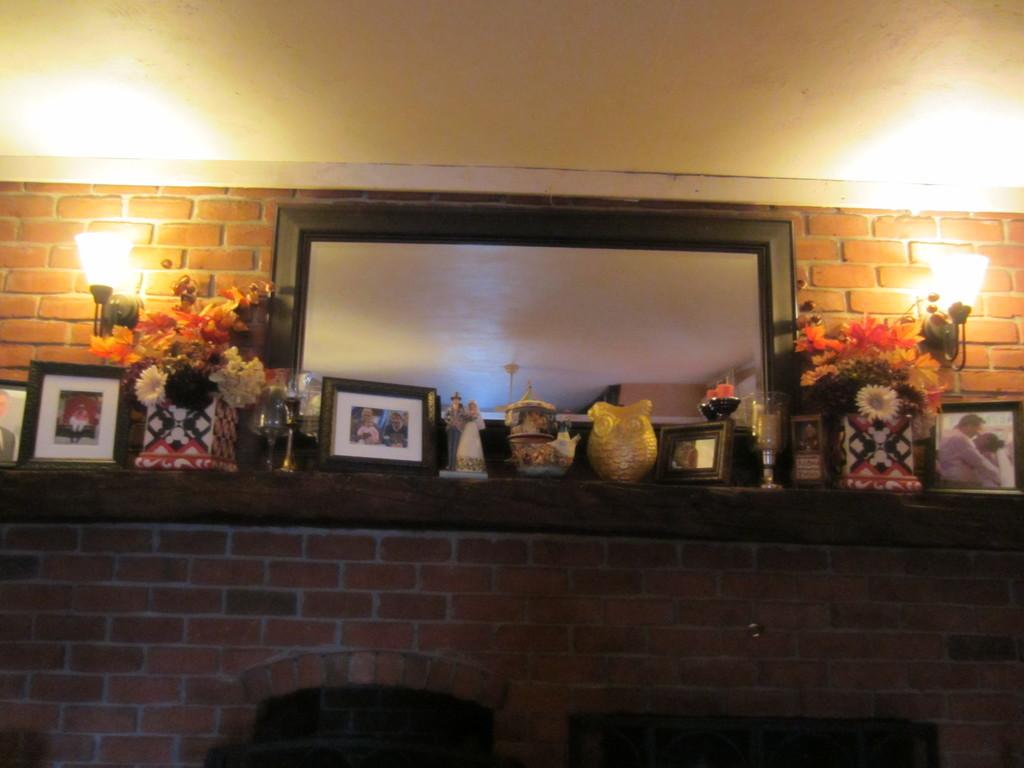What is present on the wall in the image? There are photo frames, jars, flowers, and toys on the wall in the image. Can you describe the lights visible in the image? The lights are visible in the image, but their specific type or arrangement is not mentioned. What part of the building is visible in the image? The roof is visible in the image. Are there any bats flying around in the image? There is no mention of bats in the image, so we cannot confirm their presence. Is the wall covered in sleet in the image? There is no mention of sleet in the image, so we cannot confirm its presence. 